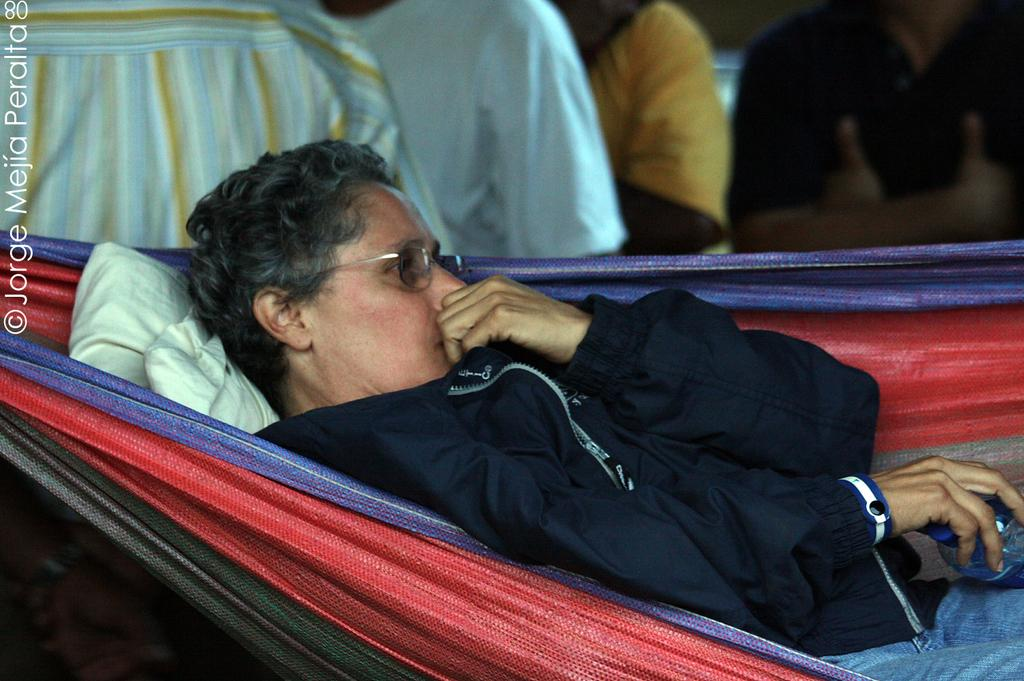What is the person in the image doing? The person is lying in a rope outdoor swing. What is the person holding in their hand? The person is holding a bottle in their hand. Are there any other people visible in the image? Yes, there are other people standing behind the person in the swing. What type of wrench is the rabbit holding while riding the bike in the image? There is no rabbit or bike present in the image, and therefore no such activity can be observed. 